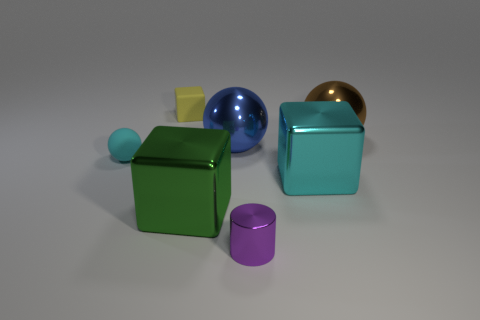There is a ball that is both right of the yellow thing and on the left side of the brown metal thing; what color is it?
Your answer should be very brief. Blue. There is a cyan thing that is the same size as the blue object; what is its shape?
Ensure brevity in your answer.  Cube. Are there any matte things that have the same color as the tiny ball?
Offer a terse response. No. Are there an equal number of large cyan shiny cubes that are behind the blue ball and big objects?
Offer a very short reply. No. Do the shiny cylinder and the tiny rubber cube have the same color?
Provide a short and direct response. No. What size is the ball that is on the right side of the green object and on the left side of the brown metallic ball?
Your answer should be compact. Large. What is the color of the ball that is the same material as the yellow object?
Your answer should be very brief. Cyan. What number of other objects are the same material as the green object?
Provide a succinct answer. 4. Are there the same number of metallic cylinders in front of the small cyan rubber sphere and big metal things behind the large blue shiny sphere?
Your answer should be very brief. Yes. Is the shape of the brown metal thing the same as the cyan object to the left of the cylinder?
Offer a terse response. Yes. 